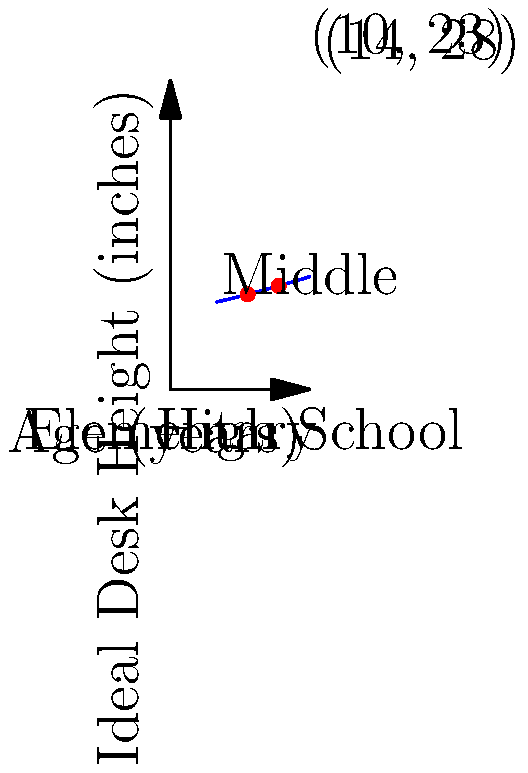Based on the graph showing the relationship between a student's age and the ideal desk height, what is the approximate difference in recommended desk height between a 10-year-old elementary school student and a 14-year-old middle school student? How might this information inform decisions about computer workstation ergonomics in your district? To solve this problem, we'll follow these steps:

1. Identify the desk heights for the two age groups:
   - For a 10-year-old: The graph shows a point at (10, 23), indicating a desk height of 23 inches.
   - For a 14-year-old: The graph shows a point at (14, 28), indicating a desk height of 28 inches.

2. Calculate the difference:
   $28 \text{ inches} - 23 \text{ inches} = 5 \text{ inches}$

3. Interpretation for the district:
   - This 5-inch difference highlights the need for adjustable workstations or different sized furniture for various age groups.
   - Elementary schools (typically ages 5-11) may require lower desks compared to middle schools (ages 11-14) and high schools (ages 14-18).
   - Adjustable chairs and desks can accommodate the rapid growth during these years, ensuring proper ergonomics for all students.
   - For computer workstations, consider:
     a) Adjustable monitor heights
     b) Keyboard trays at appropriate heights
     c) Chairs with adjustable heights and back support

4. Implementation strategies:
   - Conduct ergonomic assessments in each school level
   - Invest in adjustable furniture for computer labs and classrooms
   - Provide training for teachers and students on proper ergonomics
   - Regular review and adjustment of workstations as students grow

By addressing these ergonomic considerations, the district can potentially reduce strain-related injuries, improve posture, and create a more comfortable learning environment, ultimately supporting better academic performance and narrowing the digital divide.
Answer: 5 inches; Invest in adjustable furniture and conduct regular ergonomic assessments. 